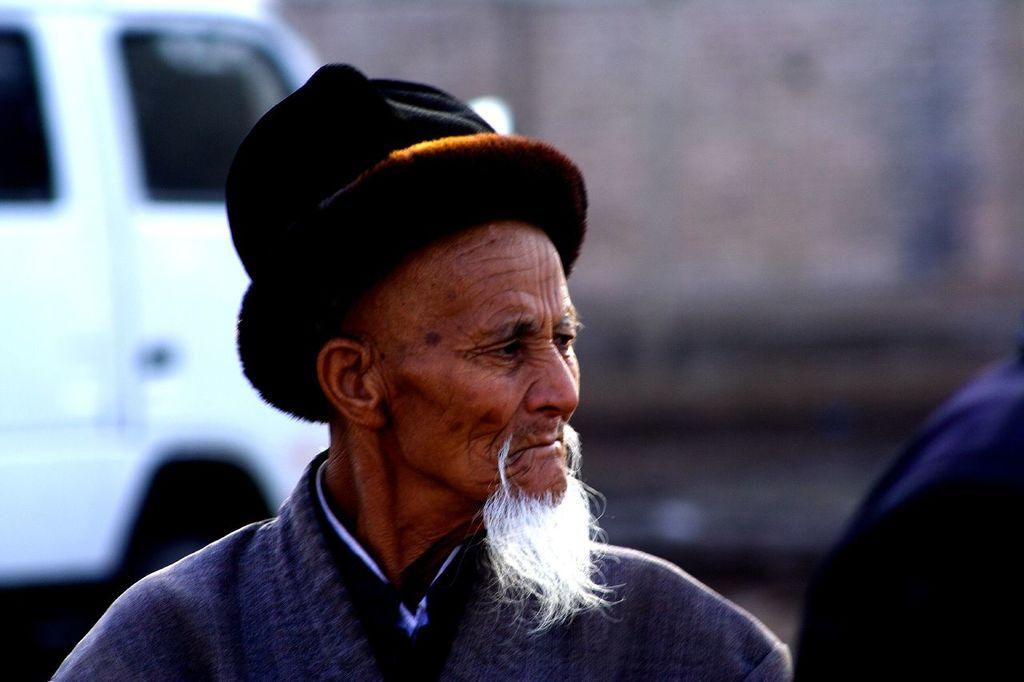Who is the main subject in the image? There is a man in the center of the image. What is the man wearing on his head? The man is wearing a cap. What can be seen in the background of the image? There is a vehicle in the background of the image. Can you describe the person on the right side of the image? There is a person on the right side of the image. What type of salt is being used by the man in the image? There is no salt present in the image, and the man is not using any salt. What story is the man telling in the image? The image does not depict the man telling a story, so we cannot determine what story he might be telling. 